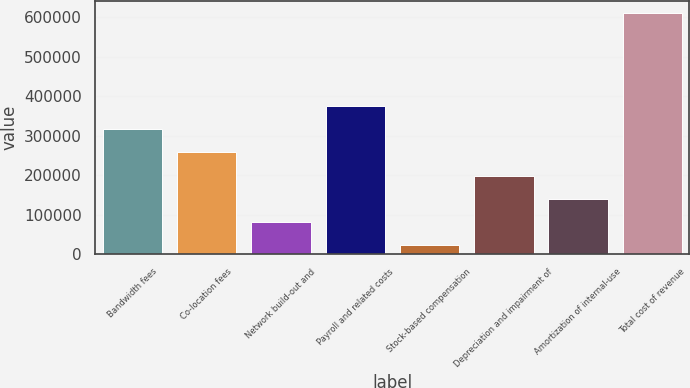Convert chart. <chart><loc_0><loc_0><loc_500><loc_500><bar_chart><fcel>Bandwidth fees<fcel>Co-location fees<fcel>Network build-out and<fcel>Payroll and related costs<fcel>Stock-based compensation<fcel>Depreciation and impairment of<fcel>Amortization of internal-use<fcel>Total cost of revenue<nl><fcel>316404<fcel>257497<fcel>80773.7<fcel>375312<fcel>21866<fcel>198589<fcel>139681<fcel>610943<nl></chart> 